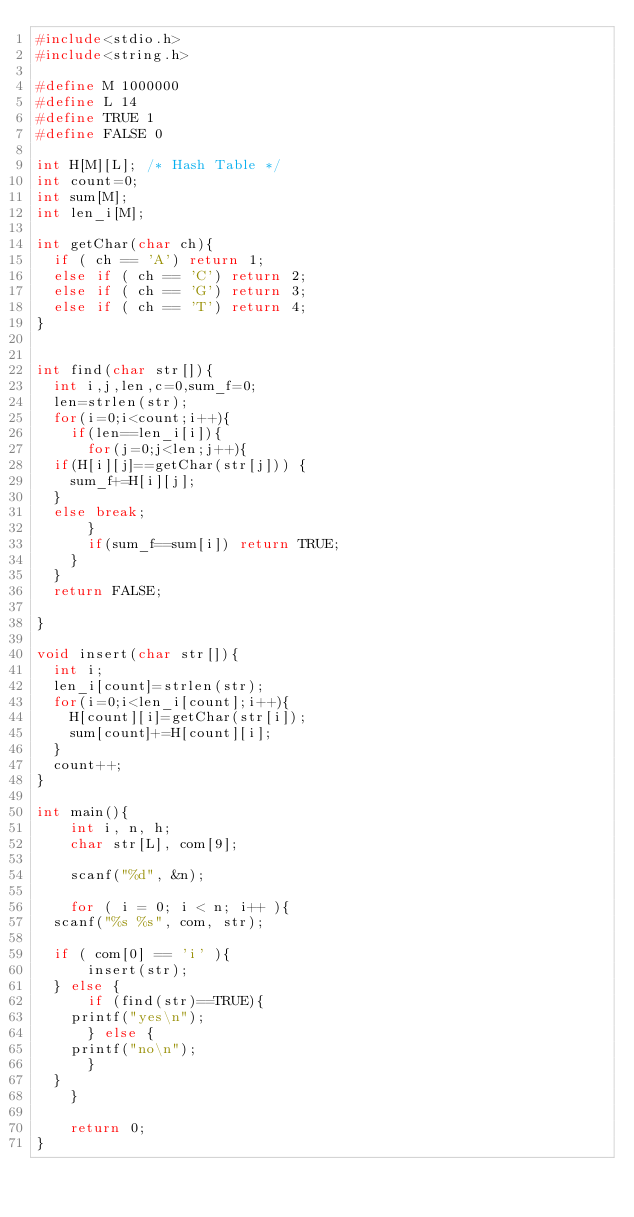<code> <loc_0><loc_0><loc_500><loc_500><_C_>#include<stdio.h>
#include<string.h>

#define M 1000000
#define L 14
#define TRUE 1
#define FALSE 0

int H[M][L]; /* Hash Table */
int count=0;
int sum[M];
int len_i[M];

int getChar(char ch){
  if ( ch == 'A') return 1;
  else if ( ch == 'C') return 2;
  else if ( ch == 'G') return 3;
  else if ( ch == 'T') return 4;
}


int find(char str[]){
  int i,j,len,c=0,sum_f=0;
  len=strlen(str);
  for(i=0;i<count;i++){
    if(len==len_i[i]){
      for(j=0;j<len;j++){
	if(H[i][j]==getChar(str[j])) {
	  sum_f+=H[i][j];	
	}
	else break;
      }
      if(sum_f==sum[i]) return TRUE;
    }
  }
  return FALSE;

}

void insert(char str[]){
  int i;
  len_i[count]=strlen(str);
  for(i=0;i<len_i[count];i++){
    H[count][i]=getChar(str[i]);
    sum[count]+=H[count][i];
  }
  count++;
}

int main(){
    int i, n, h;
    char str[L], com[9];
    
    scanf("%d", &n);
    
    for ( i = 0; i < n; i++ ){
	scanf("%s %s", com, str);
	
	if ( com[0] == 'i' ){
	    insert(str);
	} else {
	    if (find(str)==TRUE){
		printf("yes\n");
	    } else {
		printf("no\n");
	    }
	}
    }

    return 0;
}</code> 